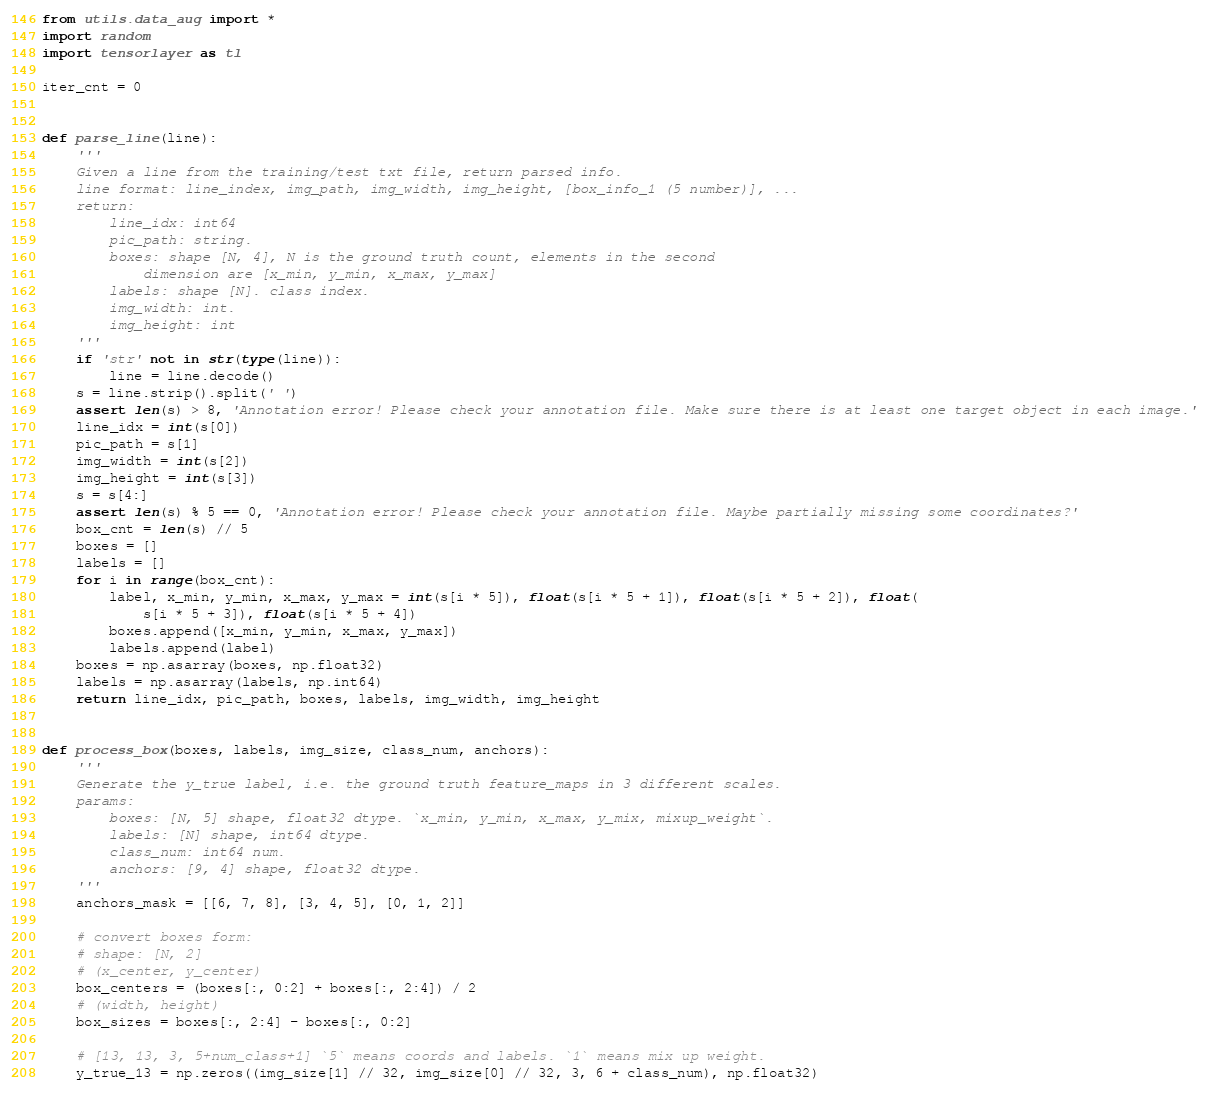Convert code to text. <code><loc_0><loc_0><loc_500><loc_500><_Python_>from utils.data_aug import *
import random
import tensorlayer as tl

iter_cnt = 0


def parse_line(line):
    '''
    Given a line from the training/test txt file, return parsed info.
    line format: line_index, img_path, img_width, img_height, [box_info_1 (5 number)], ...
    return:
        line_idx: int64
        pic_path: string.
        boxes: shape [N, 4], N is the ground truth count, elements in the second
            dimension are [x_min, y_min, x_max, y_max]
        labels: shape [N]. class index.
        img_width: int.
        img_height: int
    '''
    if 'str' not in str(type(line)):
        line = line.decode()
    s = line.strip().split(' ')
    assert len(s) > 8, 'Annotation error! Please check your annotation file. Make sure there is at least one target object in each image.'
    line_idx = int(s[0])
    pic_path = s[1]
    img_width = int(s[2])
    img_height = int(s[3])
    s = s[4:]
    assert len(s) % 5 == 0, 'Annotation error! Please check your annotation file. Maybe partially missing some coordinates?'
    box_cnt = len(s) // 5
    boxes = []
    labels = []
    for i in range(box_cnt):
        label, x_min, y_min, x_max, y_max = int(s[i * 5]), float(s[i * 5 + 1]), float(s[i * 5 + 2]), float(
            s[i * 5 + 3]), float(s[i * 5 + 4])
        boxes.append([x_min, y_min, x_max, y_max])
        labels.append(label)
    boxes = np.asarray(boxes, np.float32)
    labels = np.asarray(labels, np.int64)
    return line_idx, pic_path, boxes, labels, img_width, img_height


def process_box(boxes, labels, img_size, class_num, anchors):
    '''
    Generate the y_true label, i.e. the ground truth feature_maps in 3 different scales.
    params:
        boxes: [N, 5] shape, float32 dtype. `x_min, y_min, x_max, y_mix, mixup_weight`.
        labels: [N] shape, int64 dtype.
        class_num: int64 num.
        anchors: [9, 4] shape, float32 dtype.
    '''
    anchors_mask = [[6, 7, 8], [3, 4, 5], [0, 1, 2]]

    # convert boxes form:
    # shape: [N, 2]
    # (x_center, y_center)
    box_centers = (boxes[:, 0:2] + boxes[:, 2:4]) / 2
    # (width, height)
    box_sizes = boxes[:, 2:4] - boxes[:, 0:2]

    # [13, 13, 3, 5+num_class+1] `5` means coords and labels. `1` means mix up weight.
    y_true_13 = np.zeros((img_size[1] // 32, img_size[0] // 32, 3, 6 + class_num), np.float32)</code> 